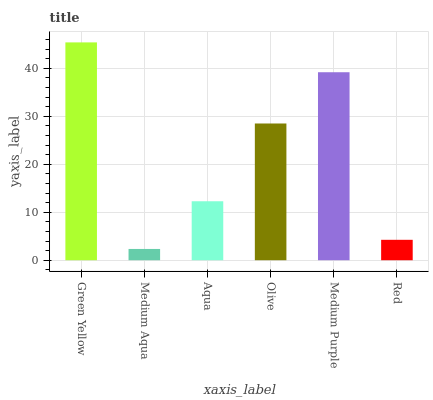Is Medium Aqua the minimum?
Answer yes or no. Yes. Is Green Yellow the maximum?
Answer yes or no. Yes. Is Aqua the minimum?
Answer yes or no. No. Is Aqua the maximum?
Answer yes or no. No. Is Aqua greater than Medium Aqua?
Answer yes or no. Yes. Is Medium Aqua less than Aqua?
Answer yes or no. Yes. Is Medium Aqua greater than Aqua?
Answer yes or no. No. Is Aqua less than Medium Aqua?
Answer yes or no. No. Is Olive the high median?
Answer yes or no. Yes. Is Aqua the low median?
Answer yes or no. Yes. Is Medium Aqua the high median?
Answer yes or no. No. Is Medium Purple the low median?
Answer yes or no. No. 